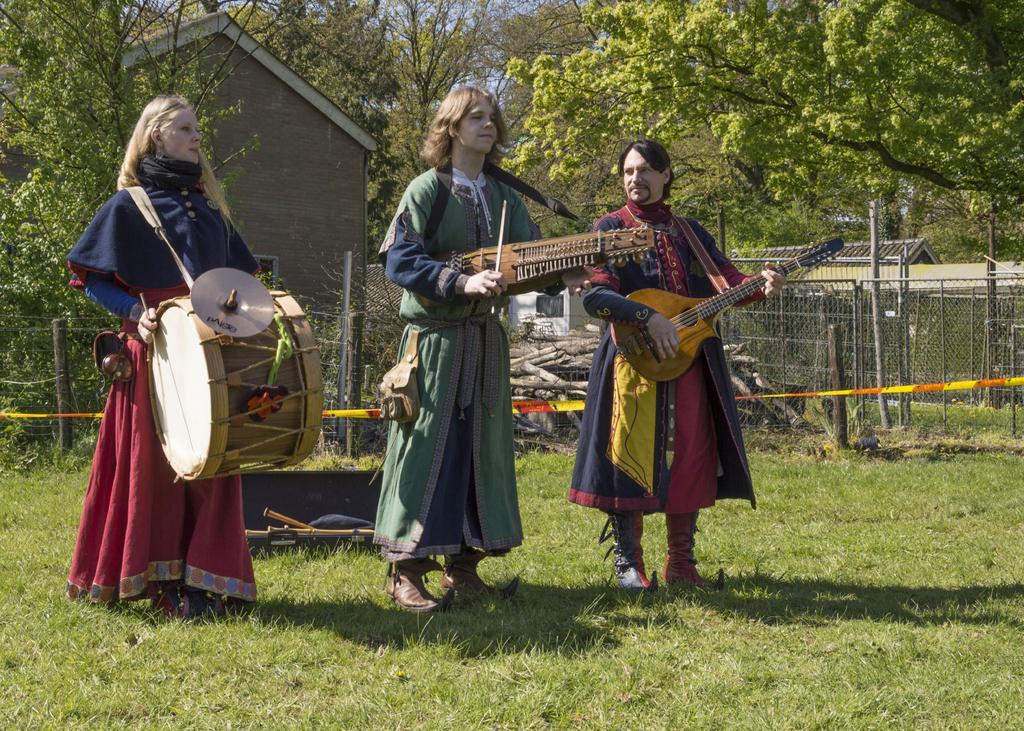Describe this image in one or two sentences. In this image I can see three people are standing and playing the musical instruments. To the back of them there is a railing and the branches. In the background there is a hut and the trees. 